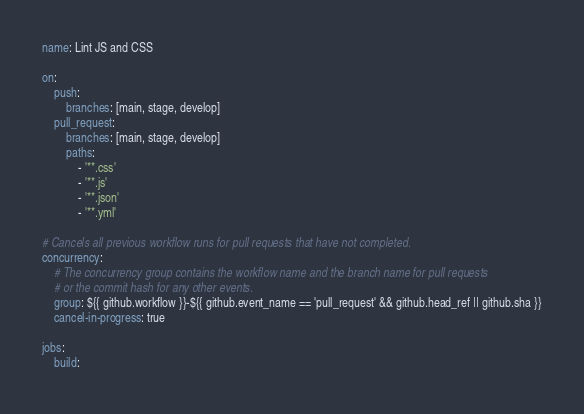<code> <loc_0><loc_0><loc_500><loc_500><_YAML_>name: Lint JS and CSS

on:
    push:
        branches: [main, stage, develop]
    pull_request:
        branches: [main, stage, develop]
        paths:
            - '**.css'
            - '**.js'
            - '**.json'
            - '**.yml'

# Cancels all previous workflow runs for pull requests that have not completed.
concurrency:
    # The concurrency group contains the workflow name and the branch name for pull requests
    # or the commit hash for any other events.
    group: ${{ github.workflow }}-${{ github.event_name == 'pull_request' && github.head_ref || github.sha }}
    cancel-in-progress: true

jobs:
    build:</code> 